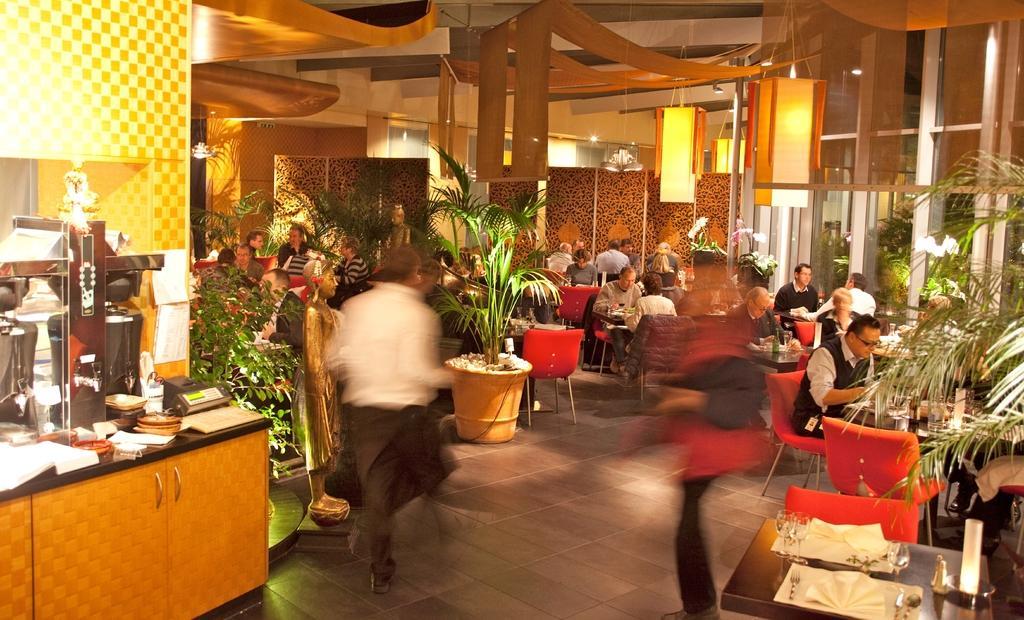Please provide a concise description of this image. In this image there are group of persons who are sitting and standing in a hotel. 